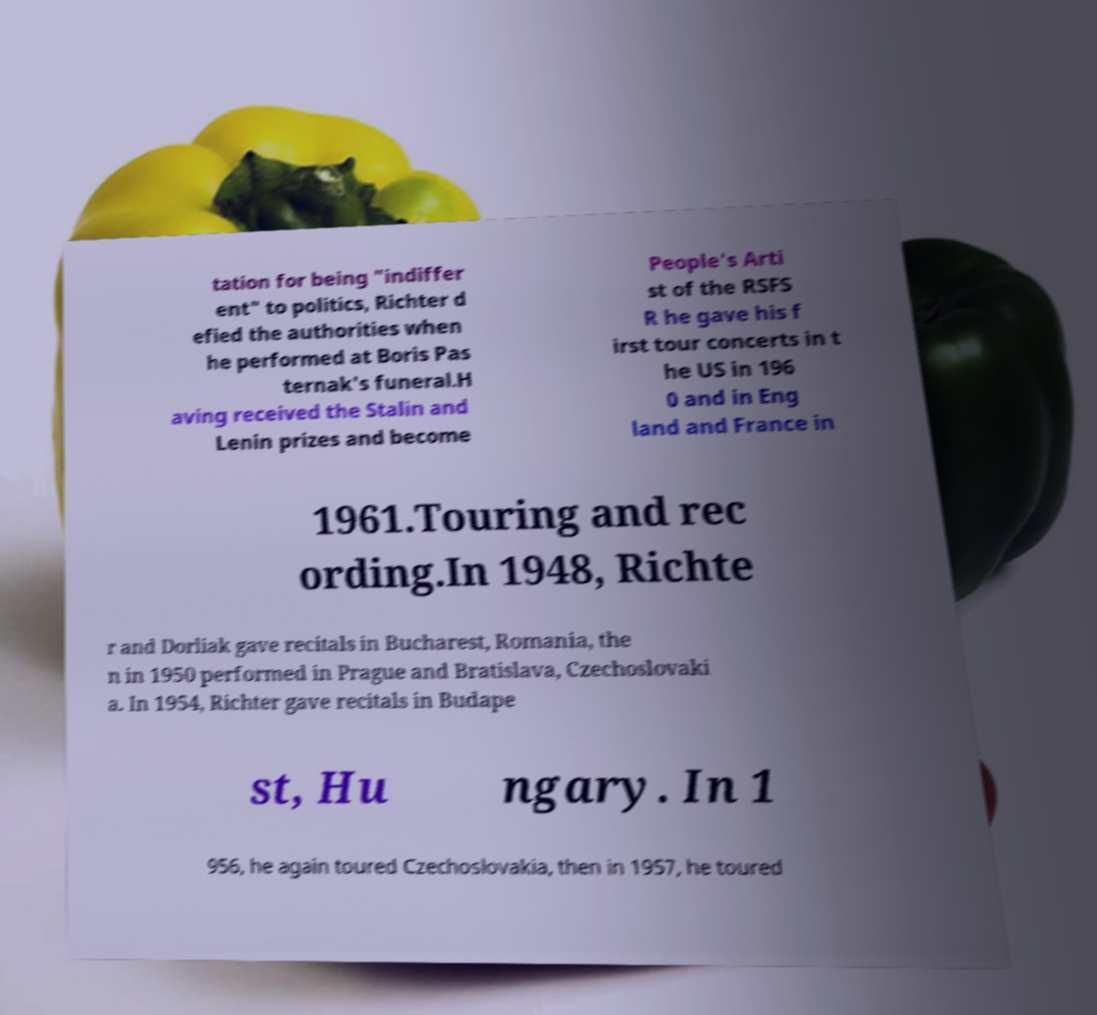For documentation purposes, I need the text within this image transcribed. Could you provide that? tation for being "indiffer ent" to politics, Richter d efied the authorities when he performed at Boris Pas ternak's funeral.H aving received the Stalin and Lenin prizes and become People's Arti st of the RSFS R he gave his f irst tour concerts in t he US in 196 0 and in Eng land and France in 1961.Touring and rec ording.In 1948, Richte r and Dorliak gave recitals in Bucharest, Romania, the n in 1950 performed in Prague and Bratislava, Czechoslovaki a. In 1954, Richter gave recitals in Budape st, Hu ngary. In 1 956, he again toured Czechoslovakia, then in 1957, he toured 